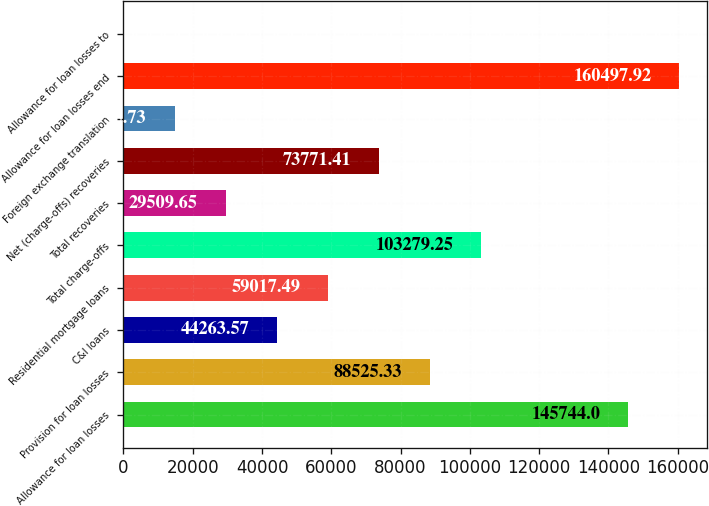<chart> <loc_0><loc_0><loc_500><loc_500><bar_chart><fcel>Allowance for loan losses<fcel>Provision for loan losses<fcel>C&I loans<fcel>Residential mortgage loans<fcel>Total charge-offs<fcel>Total recoveries<fcel>Net (charge-offs) recoveries<fcel>Foreign exchange translation<fcel>Allowance for loan losses end<fcel>Allowance for loan losses to<nl><fcel>145744<fcel>88525.3<fcel>44263.6<fcel>59017.5<fcel>103279<fcel>29509.7<fcel>73771.4<fcel>14755.7<fcel>160498<fcel>1.81<nl></chart> 